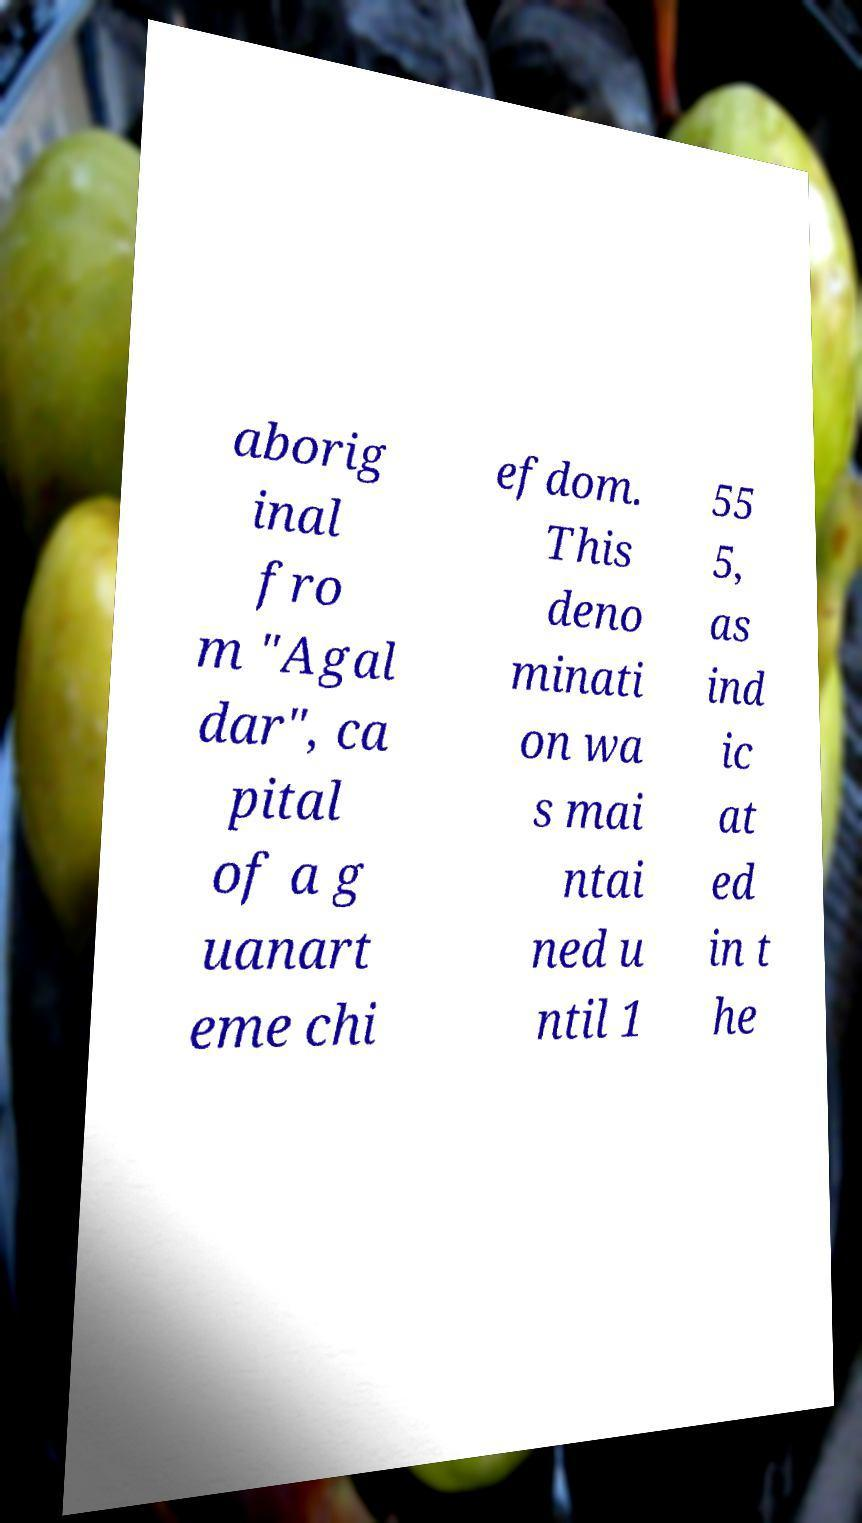I need the written content from this picture converted into text. Can you do that? aborig inal fro m "Agal dar", ca pital of a g uanart eme chi efdom. This deno minati on wa s mai ntai ned u ntil 1 55 5, as ind ic at ed in t he 